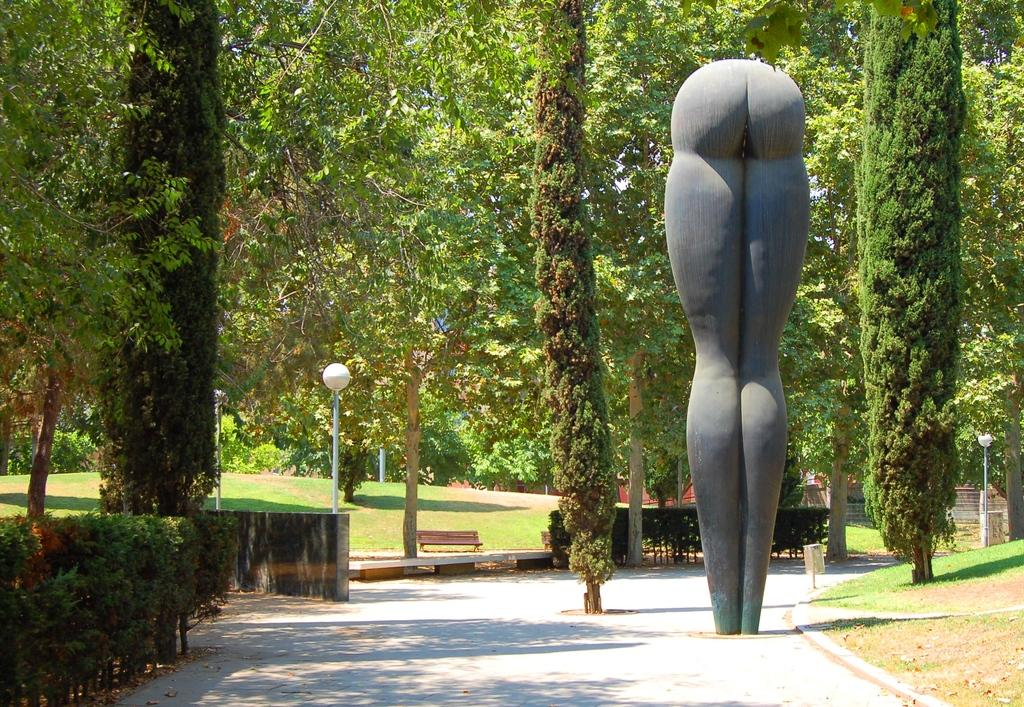What is the main structure in the image? There is a monument in the image. What is a seating option available in the image? There is a bench in the image. What type of barrier is present in the image? There is a fence in the image. What type of vegetation can be seen in the image? There are trees and shrubs in the image. What type of ground cover is visible in the image? Grass is visible in the image. What type of transportation infrastructure is present in the image? There is a road in the image. What type of fruit is hanging from the trees in the image? There is no fruit visible in the image; only trees and shrubs are present. What type of poison is being used to maintain the grass in the image? There is no mention of any poison being used to maintain the grass in the image. 